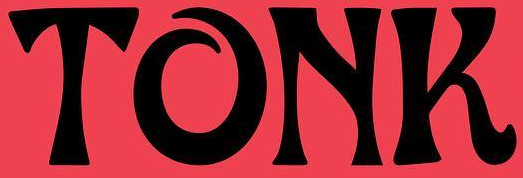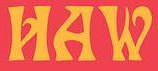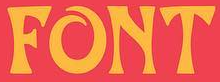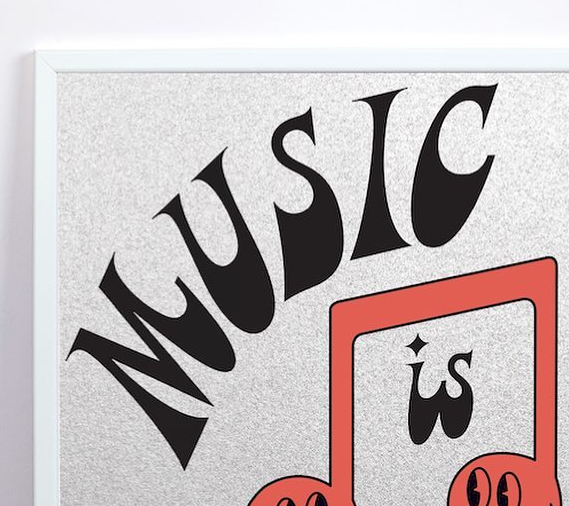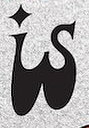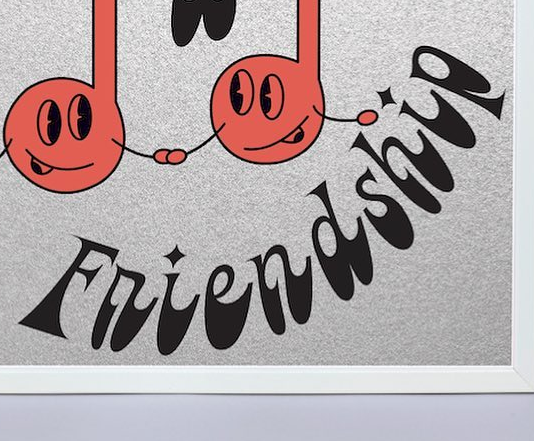Read the text from these images in sequence, separated by a semicolon. TONK; HAW; FONT; MUSIC; is; Friendship 